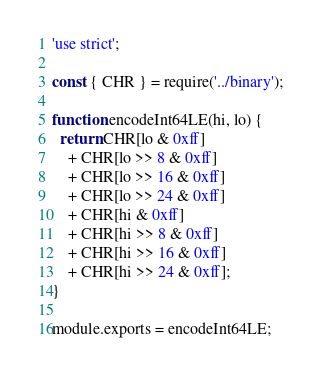<code> <loc_0><loc_0><loc_500><loc_500><_JavaScript_>'use strict';

const { CHR } = require('../binary');

function encodeInt64LE(hi, lo) {
  return CHR[lo & 0xff]
    + CHR[lo >> 8 & 0xff]
    + CHR[lo >> 16 & 0xff]
    + CHR[lo >> 24 & 0xff]
    + CHR[hi & 0xff]
    + CHR[hi >> 8 & 0xff]
    + CHR[hi >> 16 & 0xff]
    + CHR[hi >> 24 & 0xff];
}

module.exports = encodeInt64LE;
</code> 